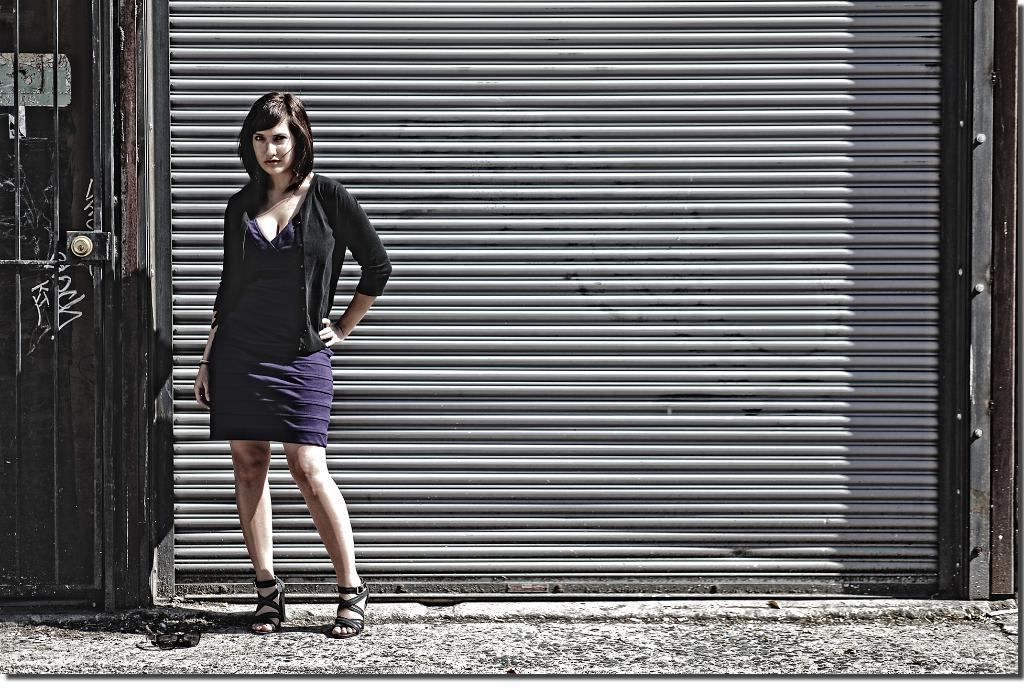Who is present in the image? There is a woman in the image. What is the woman wearing? The woman is wearing a black and blue dress. What can be seen in the background of the image? There is a shutter in the background of the image. What architectural feature is on the left side of the image? There is a door on the left side of the image. What type of surface is visible at the bottom of the image? There is a road at the bottom of the image. How many bottles can be seen in the image? There are no bottles present in the image. What is the size of the quiver in the image? There is no quiver present in the image. 